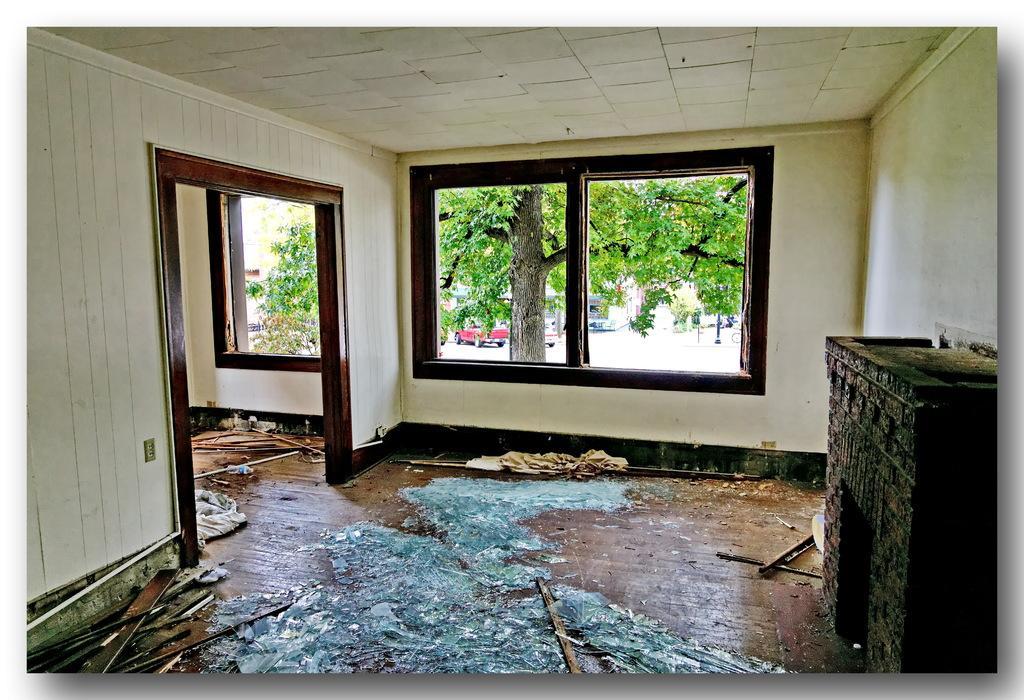Can you describe this image briefly? This picture is taken inside the room in which there is a window in the middle. Through the window we can see that there is a tree. Behind the tree there is a car. At the bottom there is a wooden floor on which there are broken pieces of glasses and wooden sticks. 